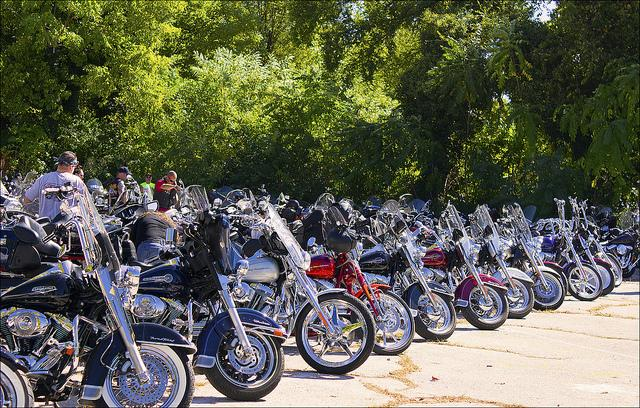Which direction are all the front wheels facing?

Choices:
A) sideways
B) right
C) straight
D) left left 